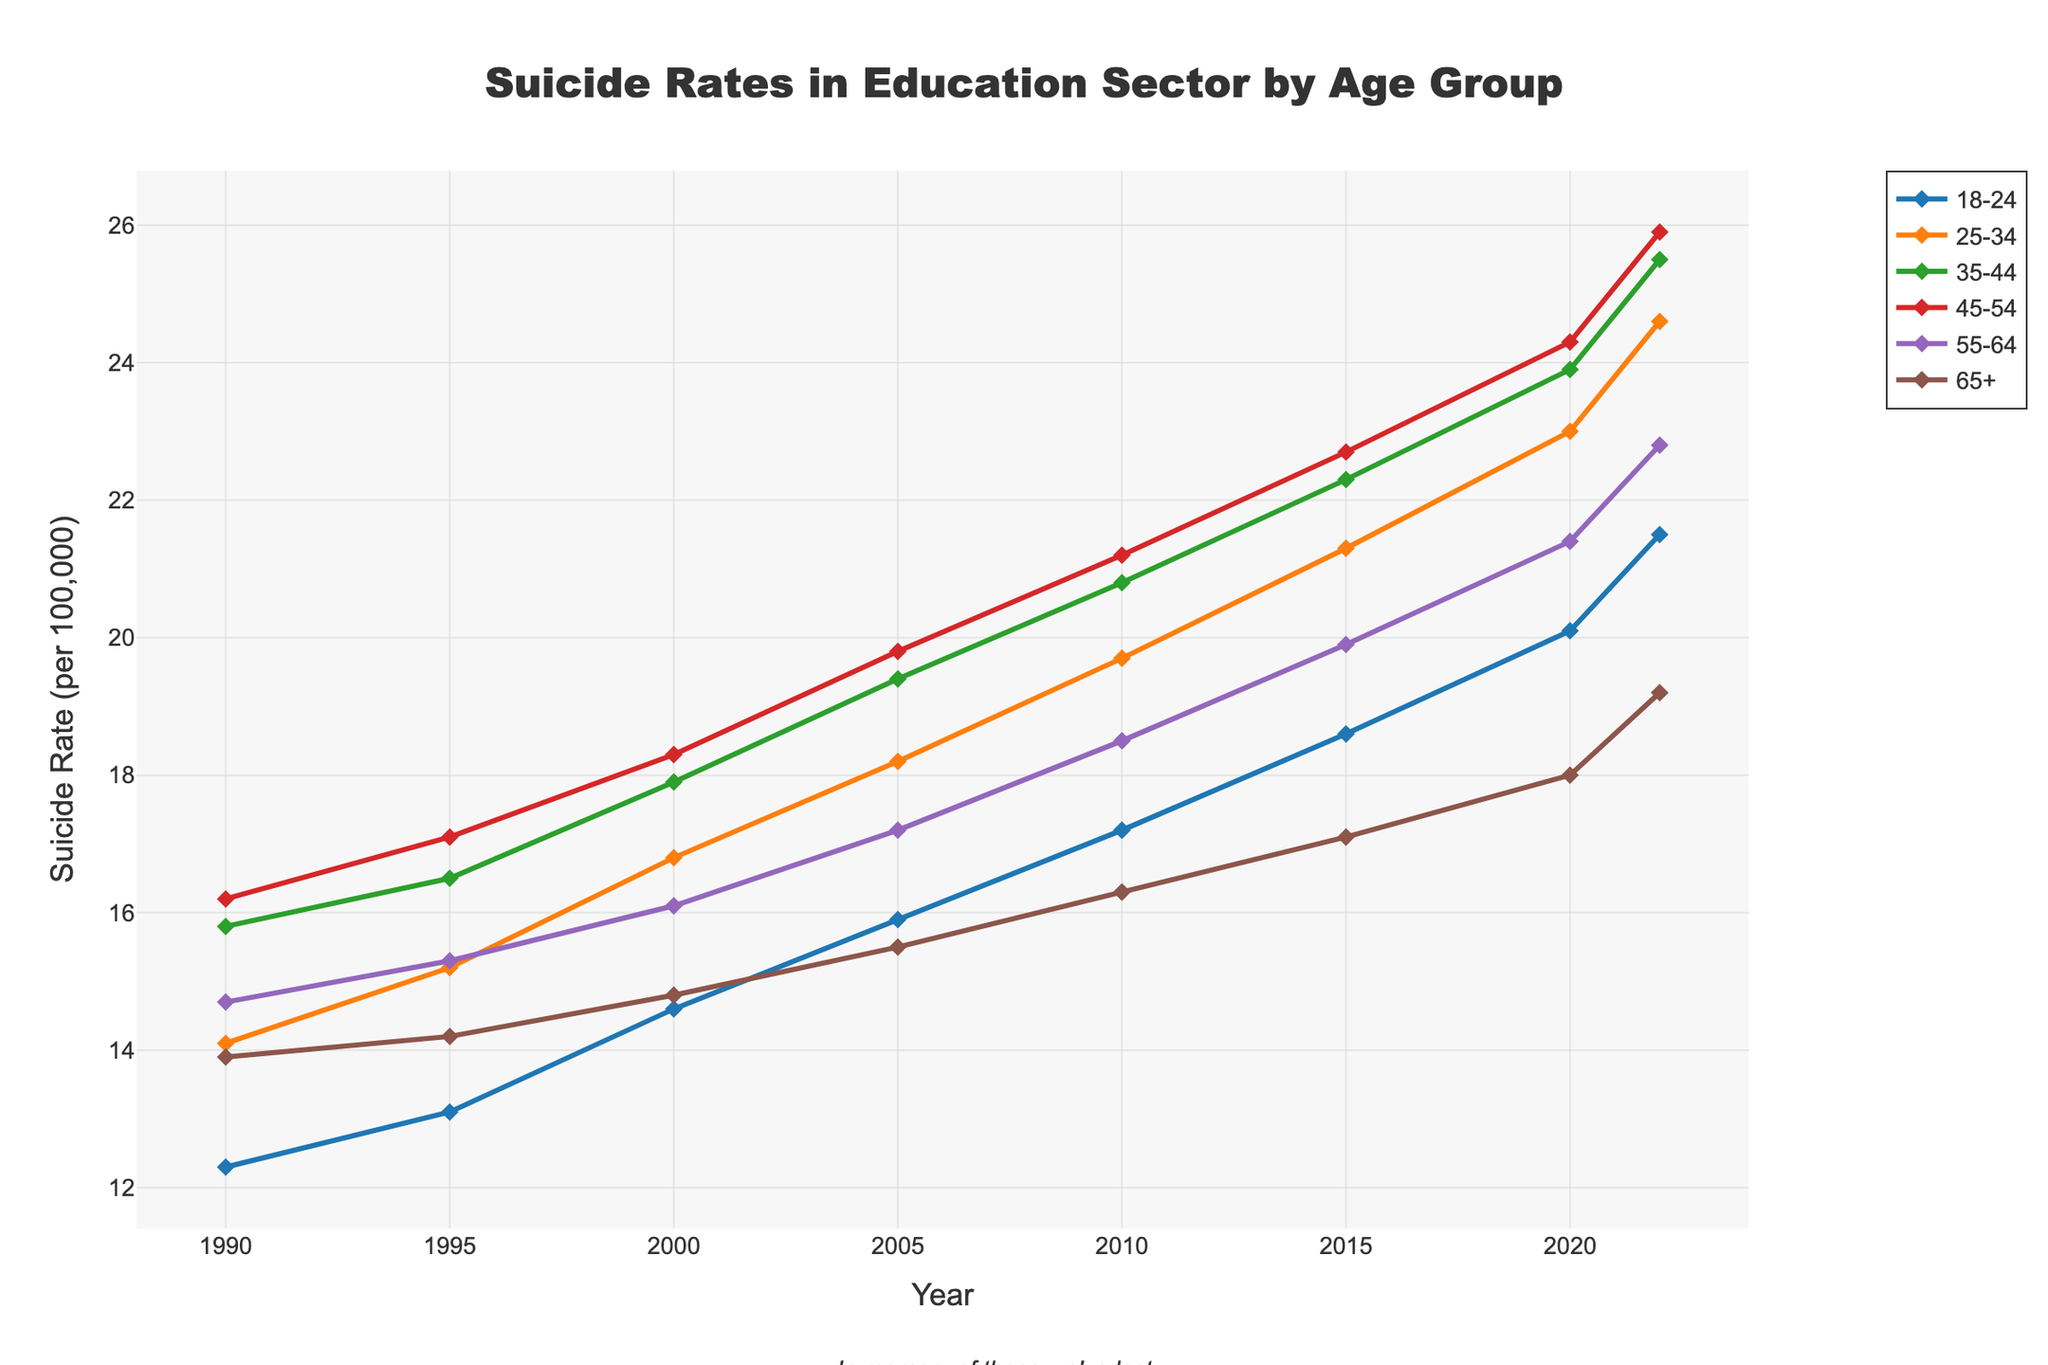What age group has the highest suicide rate in 2022? The 45-54 age group has a suicide rate of 25.9 in 2022, which is the highest compared to other age groups.
Answer: 45-54 Which age group had the lowest suicide rate in 1990? The 18-24 age group had the lowest suicide rate in 1990 with a rate of 12.3.
Answer: 18-24 How did the suicide rate for the 55-64 age group change between 1990 and 2022? The suicide rate for the 55-64 age group increased from 14.7 in 1990 to 22.8 in 2022.
Answer: Increased What is the average suicide rate for the 18-24 age group over the given time period? Summing the rates: 12.3, 13.1, 14.6, 15.9, 17.2, 18.6, 20.1, 21.5 and dividing by 8, the average rate is (12.3 + 13.1 + 14.6 + 15.9 + 17.2 + 18.6 + 20.1 + 21.5) / 8 = 16.66
Answer: 16.66 Which age group showed the largest increase in suicide rates from 1990 to 2022? The 45-54 age group showed the largest increase, from 16.2 in 1990 to 25.9 in 2022, which is an increase of 9.7.
Answer: 45-54 In which year did the 35-44 age group first surpass a suicide rate of 20 per 100,000? The 35-44 age group surpassed a suicide rate of 20 per 100,000 in 2010 with a rate of 20.8.
Answer: 2010 By what amount did the suicide rate for the 65+ age group increase from 2000 to 2022? The suicide rate for the 65+ age group increased by 4.4 from 14.8 in 2000 to 19.2 in 2022.
Answer: 4.4 Is the suicide rate of the 25-34 age group in 2022 higher or lower compared to the 35-44 age group in the same year? The suicide rate of the 25-34 age group in 2022 is 24.6, which is lower than the 35-44 age group rate of 25.5.
Answer: Lower What was the trend in the suicide rate for the 18-24 age group over the 30 years? The suicide rate for the 18-24 age group showed a steady increase from 12.3 in 1990 to 21.5 in 2022.
Answer: Increasing 